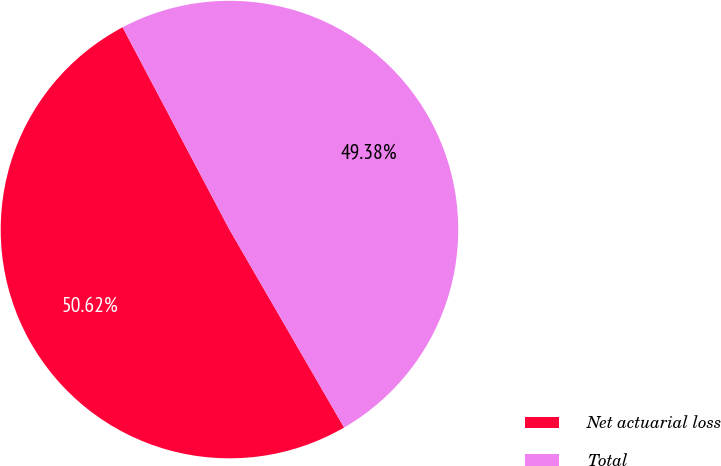Convert chart to OTSL. <chart><loc_0><loc_0><loc_500><loc_500><pie_chart><fcel>Net actuarial loss<fcel>Total<nl><fcel>50.62%<fcel>49.38%<nl></chart> 